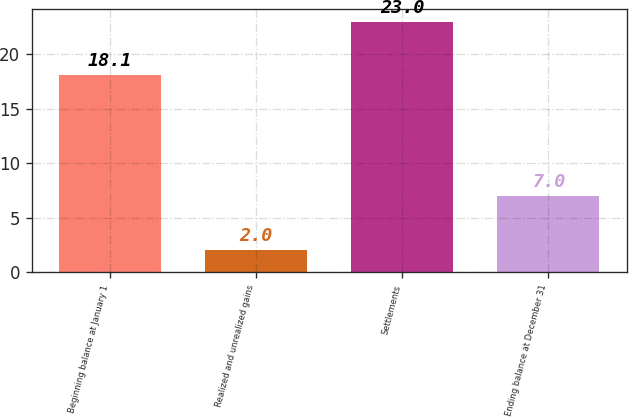Convert chart. <chart><loc_0><loc_0><loc_500><loc_500><bar_chart><fcel>Beginning balance at January 1<fcel>Realized and unrealized gains<fcel>Settlements<fcel>Ending balance at December 31<nl><fcel>18.1<fcel>2<fcel>23<fcel>7<nl></chart> 